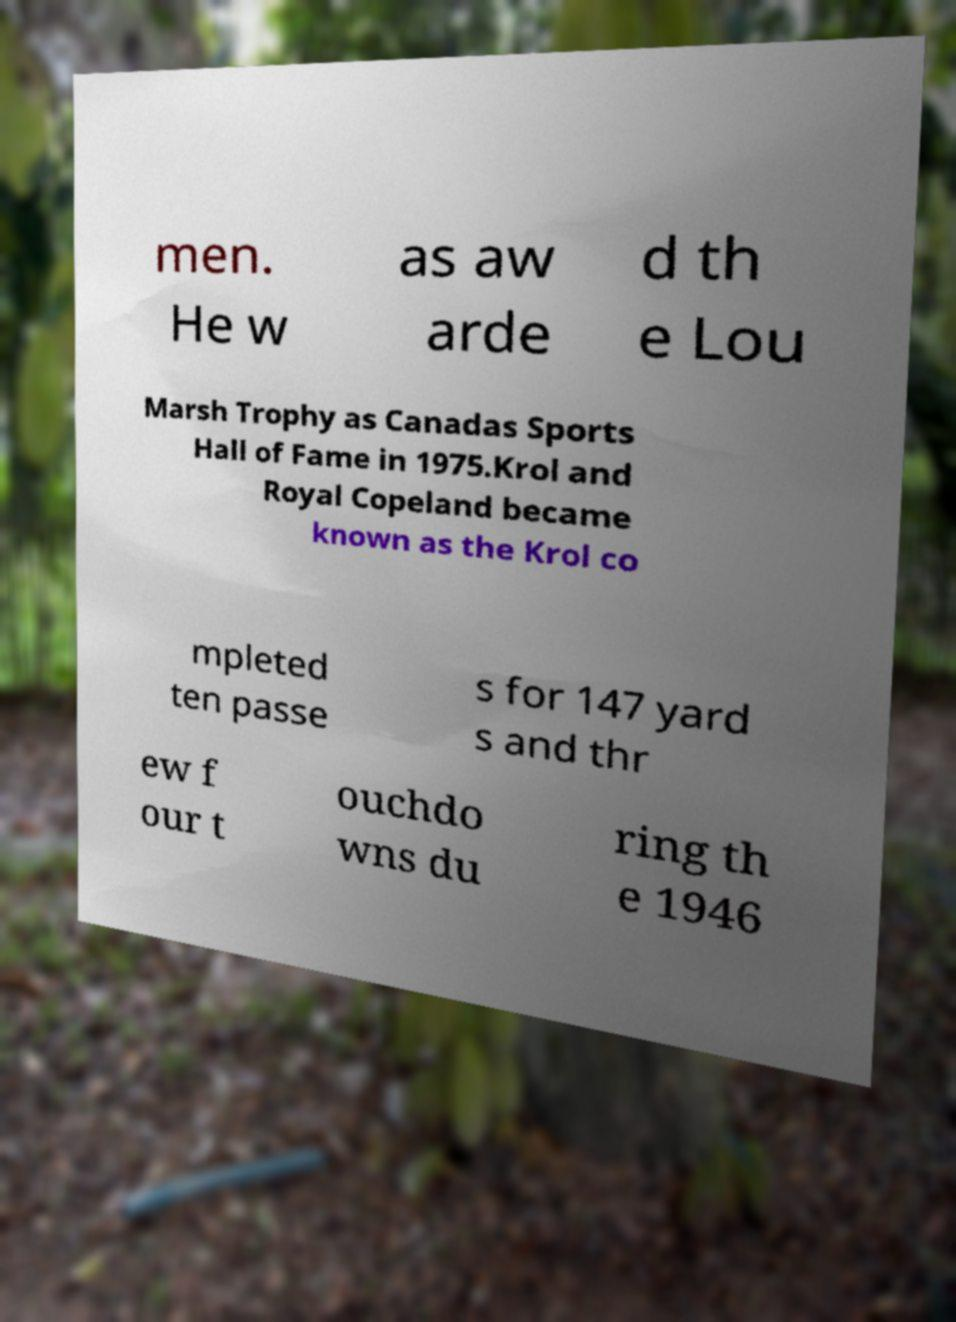I need the written content from this picture converted into text. Can you do that? men. He w as aw arde d th e Lou Marsh Trophy as Canadas Sports Hall of Fame in 1975.Krol and Royal Copeland became known as the Krol co mpleted ten passe s for 147 yard s and thr ew f our t ouchdo wns du ring th e 1946 